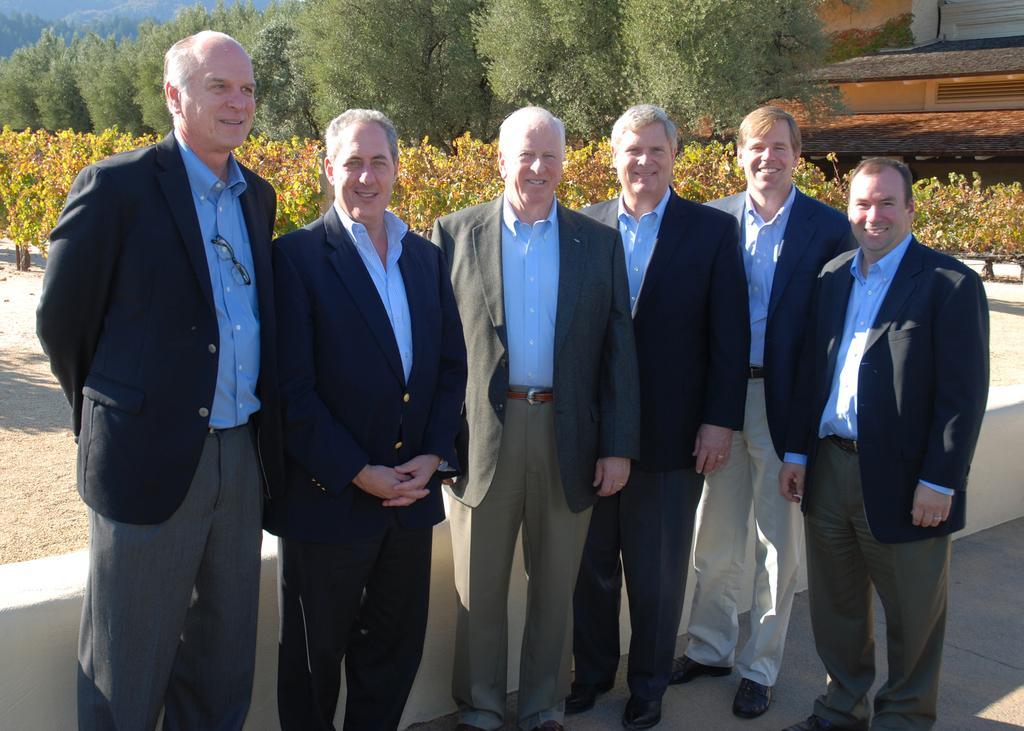In one or two sentences, can you explain what this image depicts? In the middle of the image few persons are standing and smiling. Behind them we can see a wall. Behind the wall we can see plants, trees and buildings. 